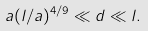Convert formula to latex. <formula><loc_0><loc_0><loc_500><loc_500>a ( l / a ) ^ { 4 / 9 } \ll d \ll l .</formula> 